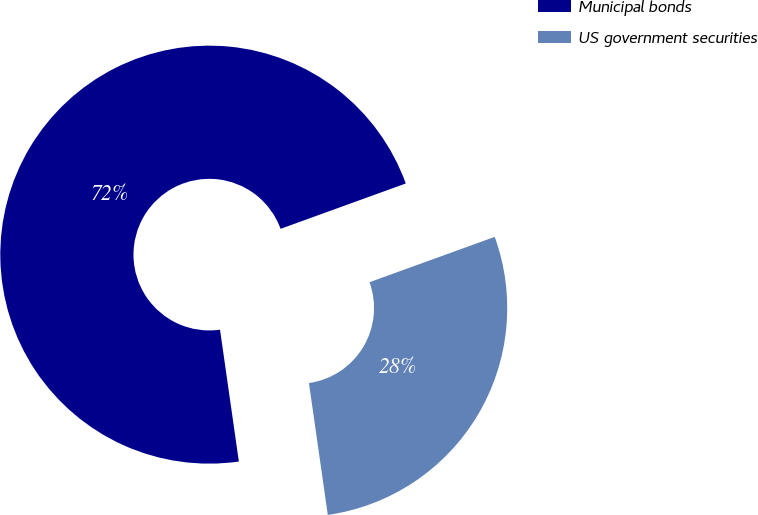<chart> <loc_0><loc_0><loc_500><loc_500><pie_chart><fcel>Municipal bonds<fcel>US government securities<nl><fcel>71.73%<fcel>28.27%<nl></chart> 